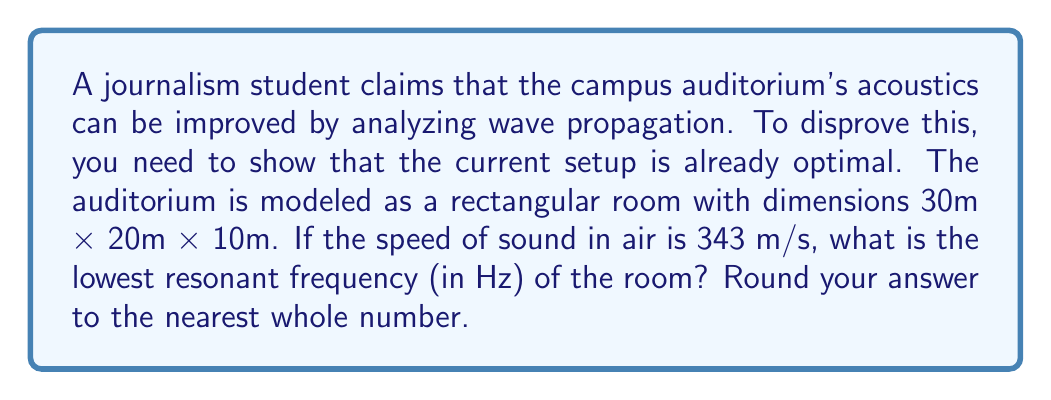Teach me how to tackle this problem. To find the lowest resonant frequency of a rectangular room, we use the equation:

$$ f = \frac{c}{2} \sqrt{\left(\frac{n_x}{L_x}\right)^2 + \left(\frac{n_y}{L_y}\right)^2 + \left(\frac{n_z}{L_z}\right)^2} $$

Where:
- $f$ is the resonant frequency
- $c$ is the speed of sound in air (343 m/s)
- $L_x$, $L_y$, and $L_z$ are the room dimensions
- $n_x$, $n_y$, and $n_z$ are integers representing the mode numbers

The lowest resonant frequency occurs when $n_x = 1$, $n_y = 0$, and $n_z = 0$.

Substituting the values:

$$ f = \frac{343}{2} \sqrt{\left(\frac{1}{30}\right)^2 + \left(\frac{0}{20}\right)^2 + \left(\frac{0}{10}\right)^2} $$

$$ f = \frac{343}{2} \sqrt{\frac{1}{900}} $$

$$ f = \frac{343}{2} \cdot \frac{1}{30} $$

$$ f = \frac{343}{60} = 5.7166... \text{ Hz} $$

Rounding to the nearest whole number:

$$ f \approx 6 \text{ Hz} $$
Answer: 6 Hz 